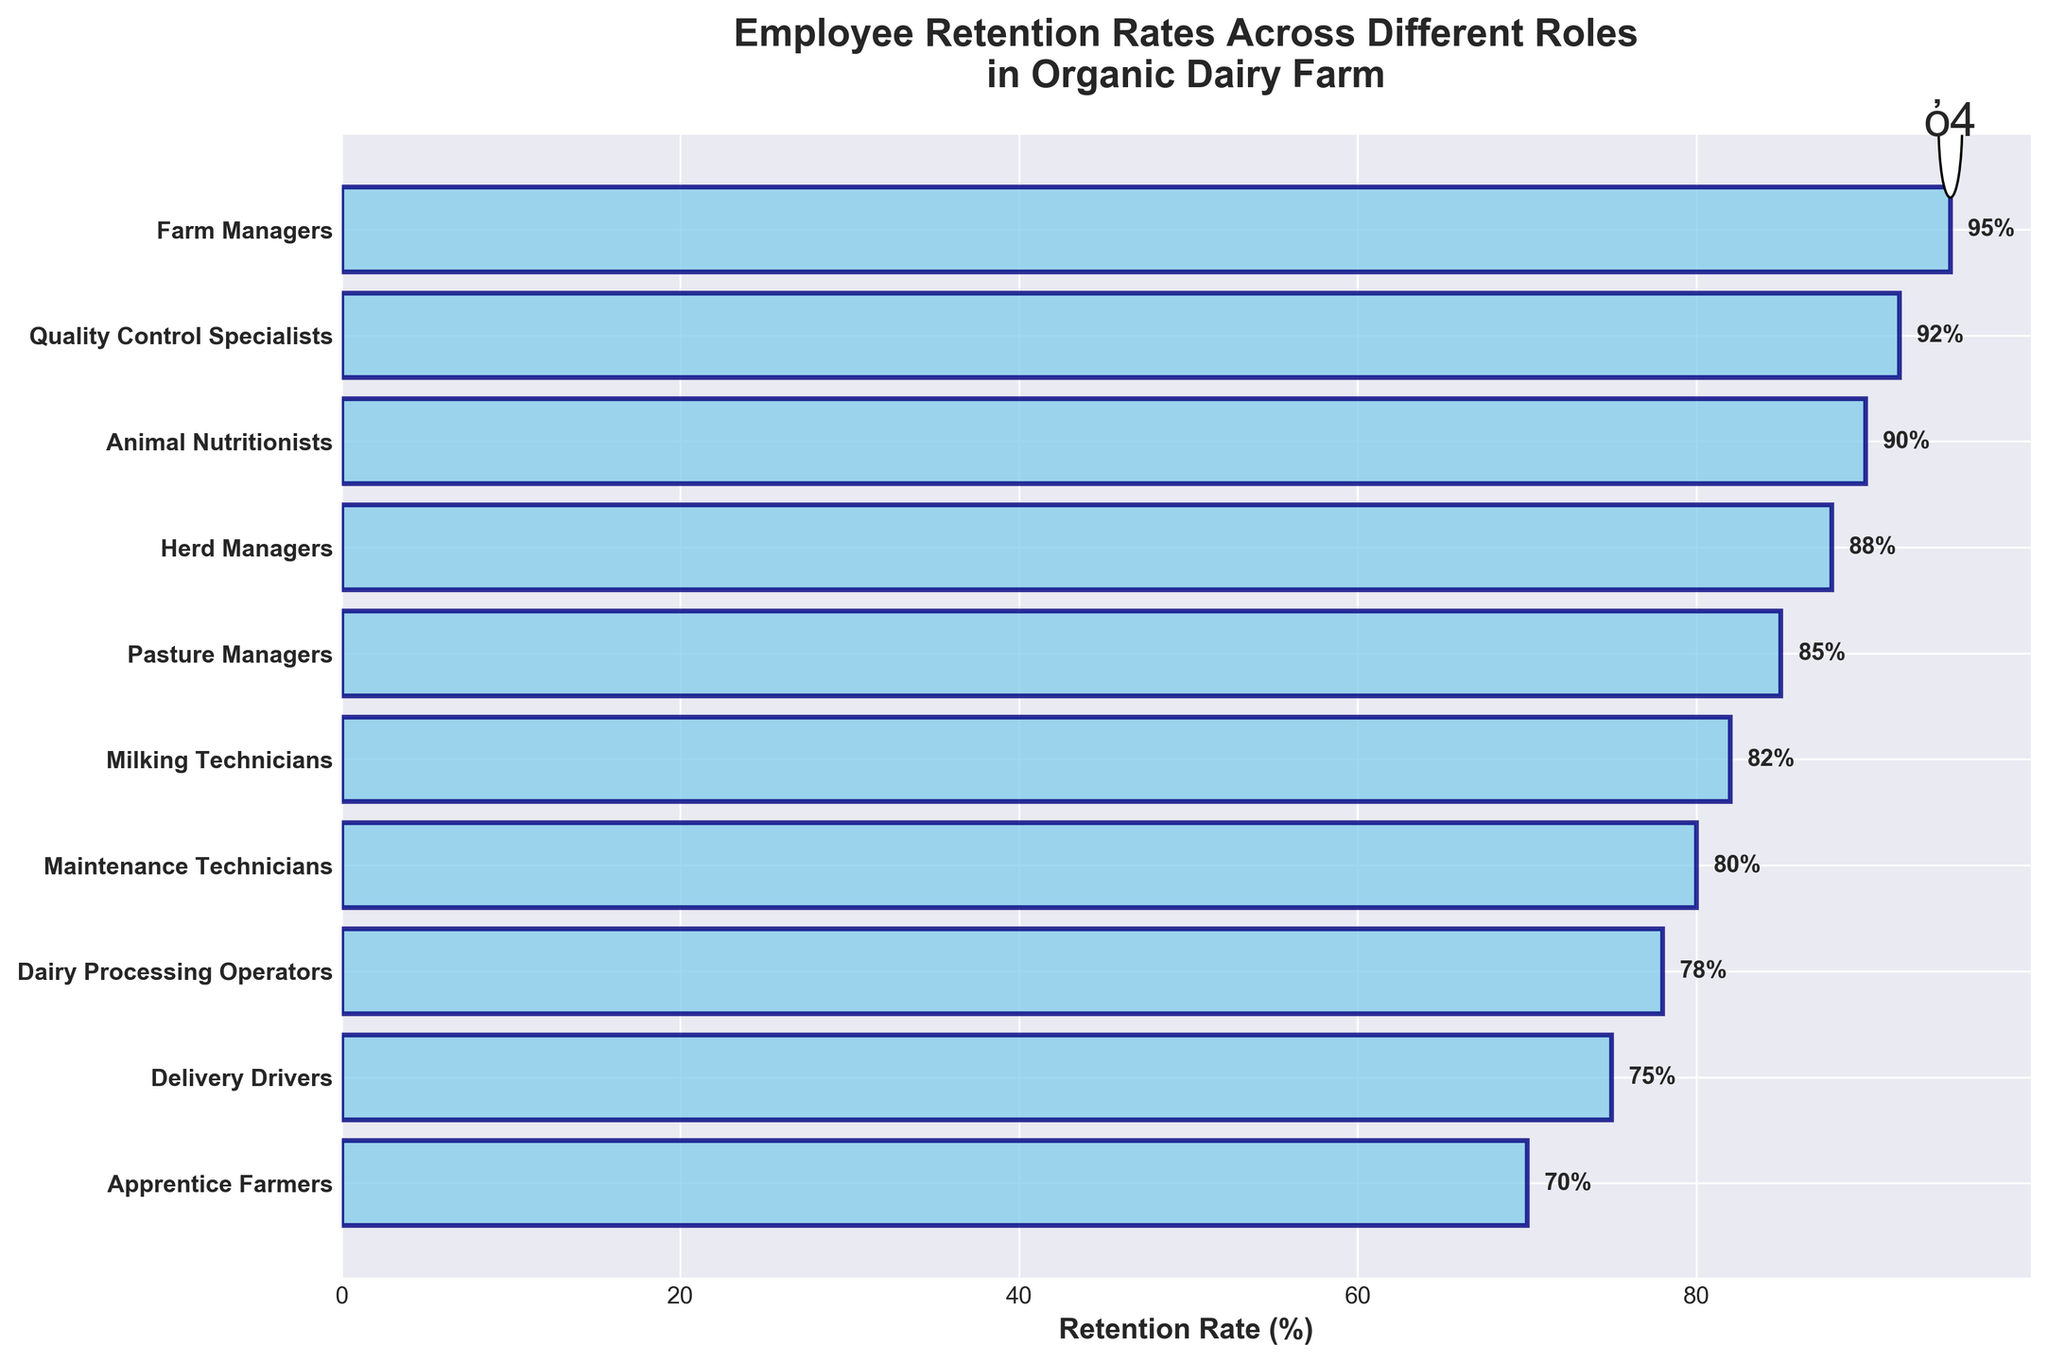What is the retention rate for Milking Technicians? Locate the 'Milking Technicians' row on the y-axis and find the corresponding bar's length on the x-axis. The retention rate is labeled as 82%.
Answer: 82% How many roles have a retention rate greater than 85%? Identify all bars with lengths exceeding 85% on the x-axis. These roles are Farm Managers, Herd Managers, Animal Nutritionists, and Quality Control Specialists, totaling four roles.
Answer: 4 Which role has the lowest retention rate? Identify the shortest bar and check its label on the y-axis. The lowest retention rate is for Apprentice Farmers at 70%.
Answer: Apprentice Farmers What is the difference in retention rates between Farm Managers and Dairy Processing Operators? Locate both roles on the y-axis. Farm Managers have a retention rate of 95% and Dairy Processing Operators have 78%. Calculate the difference: 95% - 78% = 17%.
Answer: 17% What is the average retention rate for all roles? Sum the retention rates and divide by the total number of roles: \((95 + 88 + 82 + 90 + 85 + 92 + 78 + 80 + 70 + 75) / 10 = 83.5\)
Answer: 83.5% Which two roles have the closest retention rates? Compare the retention rates of adjacent roles and identify the smallest difference. Herd Managers (88%) and Pasture Managers (85%) have the closest rates with a difference of 3%.
Answer: Herd Managers and Pasture Managers What is the retention rate range of the roles? Identify the maximum and minimum retention rates: Farm Managers (95%) and Apprentice Farmers (70%). Compute the range: 95% - 70% = 25%.
Answer: 25% How does the retention rate for Delivery Drivers compare to Maintenance Technicians? Locate both roles on the y-axis. Delivery Drivers have a retention rate of 75% and Maintenance Technicians have 80%. Delivery Drivers have a lower retention rate by 5%.
Answer: Lower by 5% Which role has the second-highest retention rate? Identify the two longest bars. Farm Managers have the highest (95%), and Quality Control Specialists have the second-highest (92%).
Answer: Quality Control Specialists Identify roles that fall below the average retention rate. The average retention rate is 83.5%. Roles below this rate are Milking Technicians (82%), Dairy Processing Operators (78%), Maintenance Technicians (80%), Apprentice Farmers (70%), and Delivery Drivers (75%).
Answer: Milking Technicians, Dairy Processing Operators, Maintenance Technicians, Apprentice Farmers, Delivery Drivers 